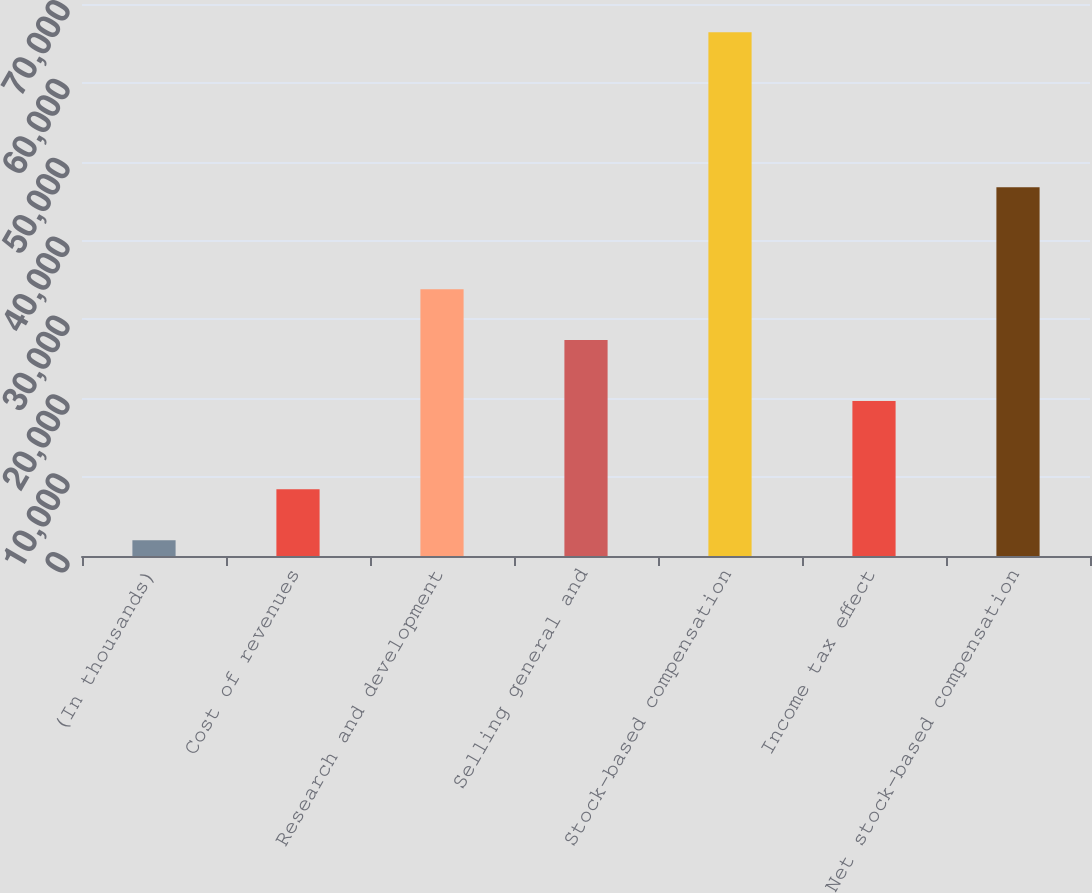Convert chart. <chart><loc_0><loc_0><loc_500><loc_500><bar_chart><fcel>(In thousands)<fcel>Cost of revenues<fcel>Research and development<fcel>Selling general and<fcel>Stock-based compensation<fcel>Income tax effect<fcel>Net stock-based compensation<nl><fcel>2008<fcel>8449.9<fcel>33830.9<fcel>27389<fcel>66427<fcel>19651<fcel>46776<nl></chart> 